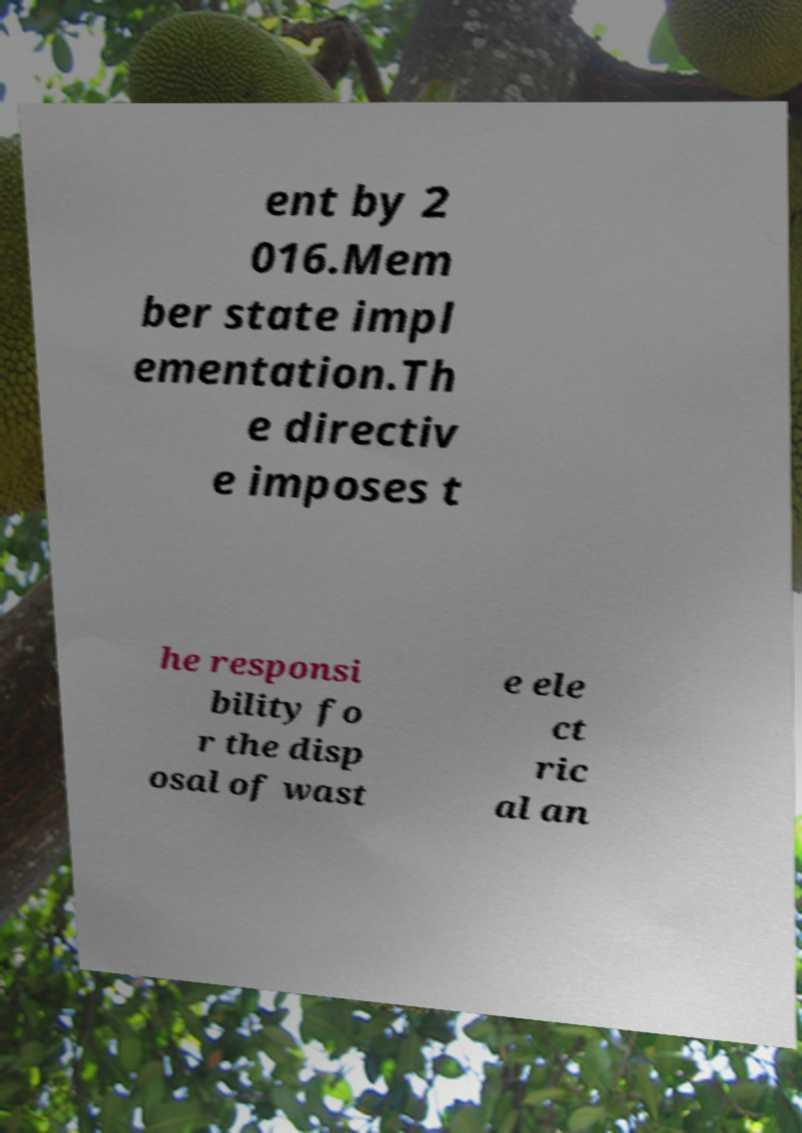Can you accurately transcribe the text from the provided image for me? ent by 2 016.Mem ber state impl ementation.Th e directiv e imposes t he responsi bility fo r the disp osal of wast e ele ct ric al an 